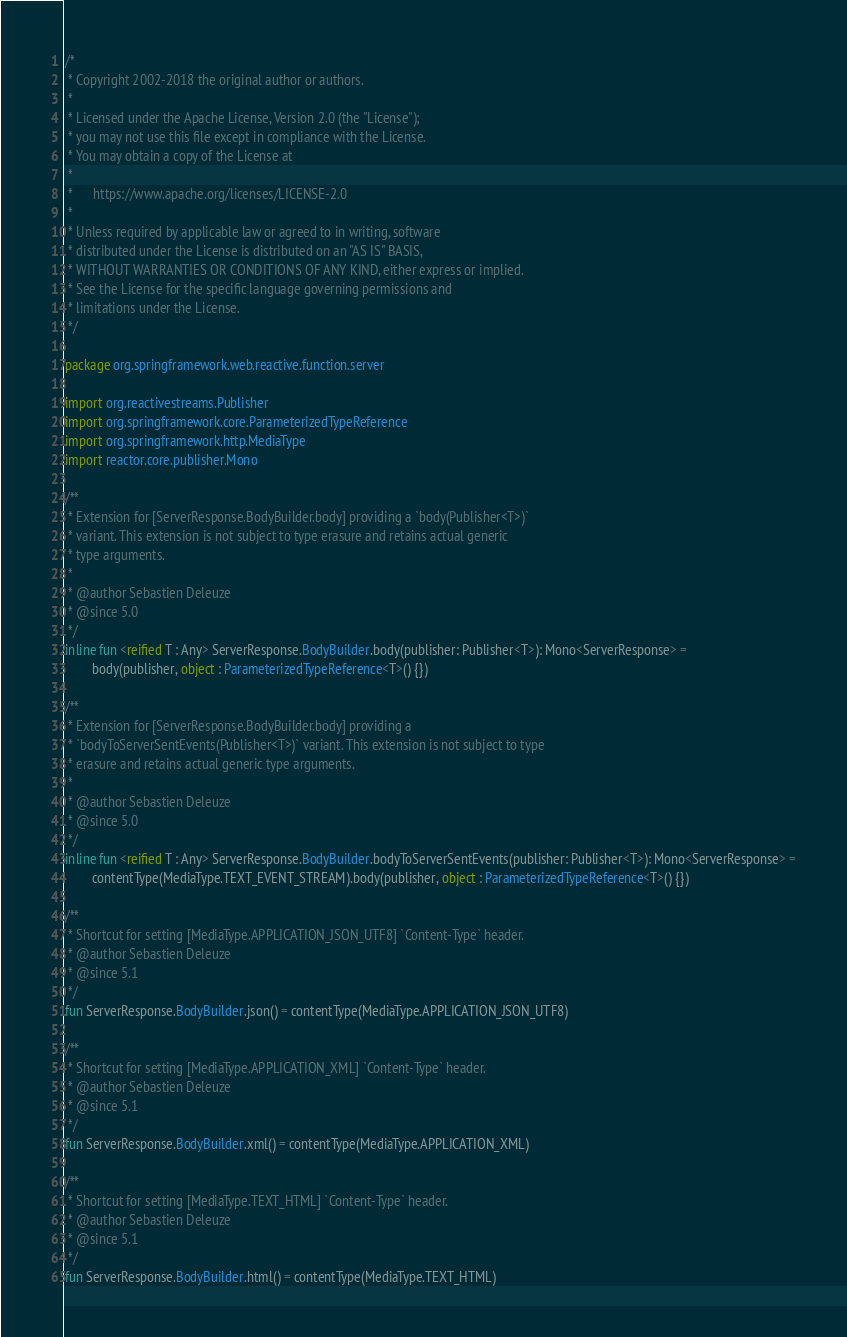Convert code to text. <code><loc_0><loc_0><loc_500><loc_500><_Kotlin_>/*
 * Copyright 2002-2018 the original author or authors.
 *
 * Licensed under the Apache License, Version 2.0 (the "License");
 * you may not use this file except in compliance with the License.
 * You may obtain a copy of the License at
 *
 *      https://www.apache.org/licenses/LICENSE-2.0
 *
 * Unless required by applicable law or agreed to in writing, software
 * distributed under the License is distributed on an "AS IS" BASIS,
 * WITHOUT WARRANTIES OR CONDITIONS OF ANY KIND, either express or implied.
 * See the License for the specific language governing permissions and
 * limitations under the License.
 */

package org.springframework.web.reactive.function.server

import org.reactivestreams.Publisher
import org.springframework.core.ParameterizedTypeReference
import org.springframework.http.MediaType
import reactor.core.publisher.Mono

/**
 * Extension for [ServerResponse.BodyBuilder.body] providing a `body(Publisher<T>)`
 * variant. This extension is not subject to type erasure and retains actual generic
 * type arguments.
 *
 * @author Sebastien Deleuze
 * @since 5.0
 */
inline fun <reified T : Any> ServerResponse.BodyBuilder.body(publisher: Publisher<T>): Mono<ServerResponse> =
		body(publisher, object : ParameterizedTypeReference<T>() {})

/**
 * Extension for [ServerResponse.BodyBuilder.body] providing a
 * `bodyToServerSentEvents(Publisher<T>)` variant. This extension is not subject to type
 * erasure and retains actual generic type arguments.
 *
 * @author Sebastien Deleuze
 * @since 5.0
 */
inline fun <reified T : Any> ServerResponse.BodyBuilder.bodyToServerSentEvents(publisher: Publisher<T>): Mono<ServerResponse> =
		contentType(MediaType.TEXT_EVENT_STREAM).body(publisher, object : ParameterizedTypeReference<T>() {})

/**
 * Shortcut for setting [MediaType.APPLICATION_JSON_UTF8] `Content-Type` header.
 * @author Sebastien Deleuze
 * @since 5.1
 */
fun ServerResponse.BodyBuilder.json() = contentType(MediaType.APPLICATION_JSON_UTF8)

/**
 * Shortcut for setting [MediaType.APPLICATION_XML] `Content-Type` header.
 * @author Sebastien Deleuze
 * @since 5.1
 */
fun ServerResponse.BodyBuilder.xml() = contentType(MediaType.APPLICATION_XML)

/**
 * Shortcut for setting [MediaType.TEXT_HTML] `Content-Type` header.
 * @author Sebastien Deleuze
 * @since 5.1
 */
fun ServerResponse.BodyBuilder.html() = contentType(MediaType.TEXT_HTML)
</code> 